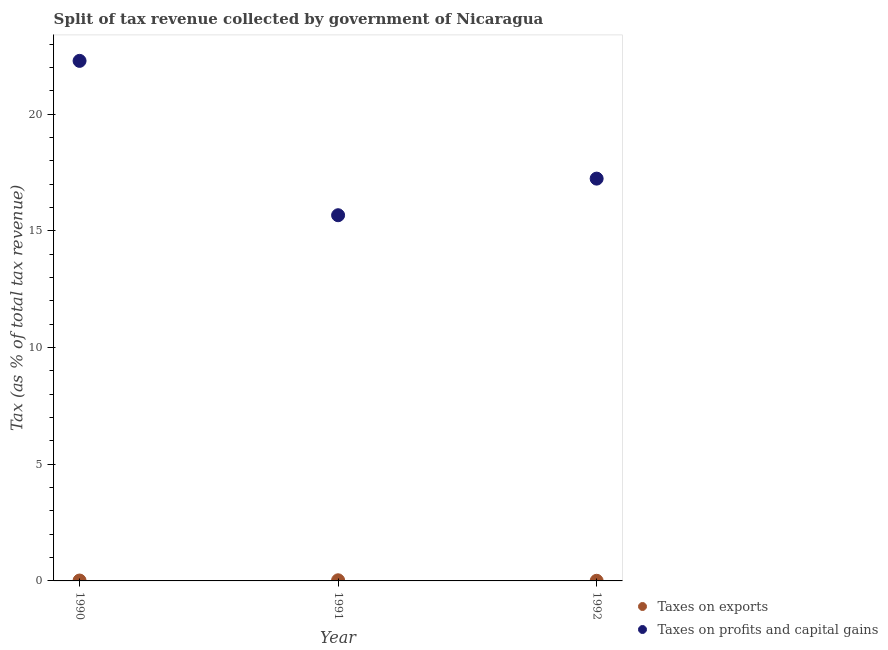What is the percentage of revenue obtained from taxes on profits and capital gains in 1991?
Offer a terse response. 15.67. Across all years, what is the maximum percentage of revenue obtained from taxes on profits and capital gains?
Ensure brevity in your answer.  22.29. Across all years, what is the minimum percentage of revenue obtained from taxes on exports?
Your response must be concise. 0.01. In which year was the percentage of revenue obtained from taxes on profits and capital gains maximum?
Your answer should be compact. 1990. What is the total percentage of revenue obtained from taxes on exports in the graph?
Ensure brevity in your answer.  0.05. What is the difference between the percentage of revenue obtained from taxes on profits and capital gains in 1991 and that in 1992?
Keep it short and to the point. -1.57. What is the difference between the percentage of revenue obtained from taxes on exports in 1990 and the percentage of revenue obtained from taxes on profits and capital gains in 1991?
Offer a very short reply. -15.66. What is the average percentage of revenue obtained from taxes on exports per year?
Offer a terse response. 0.02. In the year 1992, what is the difference between the percentage of revenue obtained from taxes on profits and capital gains and percentage of revenue obtained from taxes on exports?
Provide a short and direct response. 17.24. What is the ratio of the percentage of revenue obtained from taxes on exports in 1991 to that in 1992?
Offer a very short reply. 4.86. Is the percentage of revenue obtained from taxes on profits and capital gains in 1990 less than that in 1991?
Your answer should be very brief. No. What is the difference between the highest and the second highest percentage of revenue obtained from taxes on exports?
Your answer should be compact. 0.01. What is the difference between the highest and the lowest percentage of revenue obtained from taxes on profits and capital gains?
Make the answer very short. 6.62. Is the sum of the percentage of revenue obtained from taxes on exports in 1991 and 1992 greater than the maximum percentage of revenue obtained from taxes on profits and capital gains across all years?
Offer a terse response. No. Does the percentage of revenue obtained from taxes on exports monotonically increase over the years?
Provide a succinct answer. No. Is the percentage of revenue obtained from taxes on exports strictly greater than the percentage of revenue obtained from taxes on profits and capital gains over the years?
Provide a short and direct response. No. Does the graph contain any zero values?
Offer a terse response. No. Does the graph contain grids?
Ensure brevity in your answer.  No. How many legend labels are there?
Ensure brevity in your answer.  2. What is the title of the graph?
Offer a very short reply. Split of tax revenue collected by government of Nicaragua. What is the label or title of the Y-axis?
Provide a succinct answer. Tax (as % of total tax revenue). What is the Tax (as % of total tax revenue) in Taxes on exports in 1990?
Keep it short and to the point. 0.02. What is the Tax (as % of total tax revenue) of Taxes on profits and capital gains in 1990?
Keep it short and to the point. 22.29. What is the Tax (as % of total tax revenue) of Taxes on exports in 1991?
Provide a short and direct response. 0.03. What is the Tax (as % of total tax revenue) in Taxes on profits and capital gains in 1991?
Provide a short and direct response. 15.67. What is the Tax (as % of total tax revenue) in Taxes on exports in 1992?
Offer a very short reply. 0.01. What is the Tax (as % of total tax revenue) of Taxes on profits and capital gains in 1992?
Offer a very short reply. 17.24. Across all years, what is the maximum Tax (as % of total tax revenue) in Taxes on exports?
Your response must be concise. 0.03. Across all years, what is the maximum Tax (as % of total tax revenue) of Taxes on profits and capital gains?
Offer a terse response. 22.29. Across all years, what is the minimum Tax (as % of total tax revenue) in Taxes on exports?
Make the answer very short. 0.01. Across all years, what is the minimum Tax (as % of total tax revenue) in Taxes on profits and capital gains?
Offer a very short reply. 15.67. What is the total Tax (as % of total tax revenue) in Taxes on profits and capital gains in the graph?
Offer a terse response. 55.2. What is the difference between the Tax (as % of total tax revenue) in Taxes on exports in 1990 and that in 1991?
Provide a short and direct response. -0.01. What is the difference between the Tax (as % of total tax revenue) in Taxes on profits and capital gains in 1990 and that in 1991?
Provide a succinct answer. 6.62. What is the difference between the Tax (as % of total tax revenue) in Taxes on exports in 1990 and that in 1992?
Provide a short and direct response. 0.01. What is the difference between the Tax (as % of total tax revenue) in Taxes on profits and capital gains in 1990 and that in 1992?
Your answer should be very brief. 5.05. What is the difference between the Tax (as % of total tax revenue) in Taxes on exports in 1991 and that in 1992?
Your answer should be compact. 0.02. What is the difference between the Tax (as % of total tax revenue) in Taxes on profits and capital gains in 1991 and that in 1992?
Offer a terse response. -1.57. What is the difference between the Tax (as % of total tax revenue) of Taxes on exports in 1990 and the Tax (as % of total tax revenue) of Taxes on profits and capital gains in 1991?
Make the answer very short. -15.66. What is the difference between the Tax (as % of total tax revenue) of Taxes on exports in 1990 and the Tax (as % of total tax revenue) of Taxes on profits and capital gains in 1992?
Offer a very short reply. -17.23. What is the difference between the Tax (as % of total tax revenue) in Taxes on exports in 1991 and the Tax (as % of total tax revenue) in Taxes on profits and capital gains in 1992?
Your answer should be compact. -17.21. What is the average Tax (as % of total tax revenue) in Taxes on exports per year?
Give a very brief answer. 0.02. What is the average Tax (as % of total tax revenue) in Taxes on profits and capital gains per year?
Provide a short and direct response. 18.4. In the year 1990, what is the difference between the Tax (as % of total tax revenue) of Taxes on exports and Tax (as % of total tax revenue) of Taxes on profits and capital gains?
Ensure brevity in your answer.  -22.27. In the year 1991, what is the difference between the Tax (as % of total tax revenue) of Taxes on exports and Tax (as % of total tax revenue) of Taxes on profits and capital gains?
Your answer should be compact. -15.65. In the year 1992, what is the difference between the Tax (as % of total tax revenue) in Taxes on exports and Tax (as % of total tax revenue) in Taxes on profits and capital gains?
Provide a short and direct response. -17.24. What is the ratio of the Tax (as % of total tax revenue) of Taxes on exports in 1990 to that in 1991?
Keep it short and to the point. 0.62. What is the ratio of the Tax (as % of total tax revenue) in Taxes on profits and capital gains in 1990 to that in 1991?
Provide a short and direct response. 1.42. What is the ratio of the Tax (as % of total tax revenue) of Taxes on exports in 1990 to that in 1992?
Offer a terse response. 3.03. What is the ratio of the Tax (as % of total tax revenue) of Taxes on profits and capital gains in 1990 to that in 1992?
Provide a succinct answer. 1.29. What is the ratio of the Tax (as % of total tax revenue) in Taxes on exports in 1991 to that in 1992?
Offer a very short reply. 4.86. What is the ratio of the Tax (as % of total tax revenue) of Taxes on profits and capital gains in 1991 to that in 1992?
Keep it short and to the point. 0.91. What is the difference between the highest and the second highest Tax (as % of total tax revenue) of Taxes on exports?
Your answer should be very brief. 0.01. What is the difference between the highest and the second highest Tax (as % of total tax revenue) in Taxes on profits and capital gains?
Your answer should be very brief. 5.05. What is the difference between the highest and the lowest Tax (as % of total tax revenue) of Taxes on exports?
Keep it short and to the point. 0.02. What is the difference between the highest and the lowest Tax (as % of total tax revenue) of Taxes on profits and capital gains?
Give a very brief answer. 6.62. 